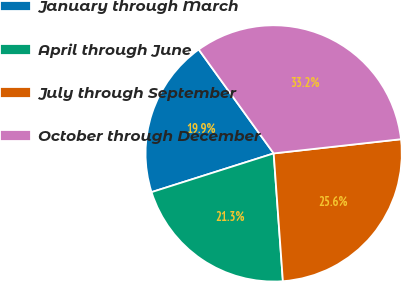Convert chart to OTSL. <chart><loc_0><loc_0><loc_500><loc_500><pie_chart><fcel>January through March<fcel>April through June<fcel>July through September<fcel>October through December<nl><fcel>19.94%<fcel>21.26%<fcel>25.62%<fcel>33.18%<nl></chart> 